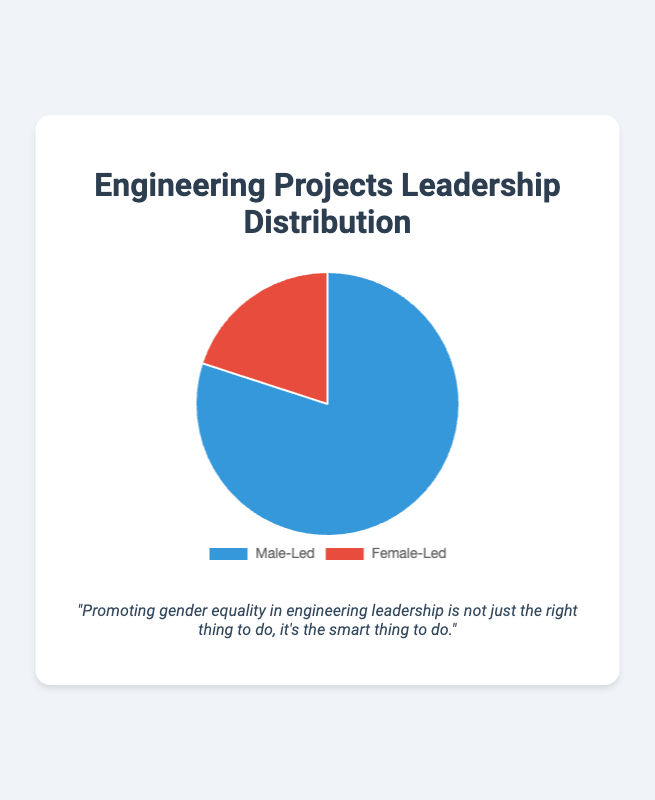Which group leads more engineering projects, Male-Led or Female-Led? The pie chart shows two segments representing Male-Led and Female-Led engineering projects. The Male-Led segment covers a larger portion of the chart.
Answer: Male-Led What is the percentage of engineering projects led by females? The pie chart labels each segment with its corresponding percentage. The Female-Led segment is labeled as 20%.
Answer: 20% What is the difference in the percentage of engineering projects led by males compared to females? The Male-Led projects account for 80%, while Female-Led projects account for 20%. The difference is 80% - 20%.
Answer: 60% If there are 100 engineering projects in total, how many of them are led by females? Given that 20% of the projects are led by females, if there are 100 total projects, then the number of Female-Led projects is 20% of 100.
Answer: 20 Estimate the ratio of Male-Led projects to Female-Led projects. The pie chart indicates 80% for Male-Led and 20% for Female-Led. The ratio can be calculated as 80:20, which simplifies to 4:1.
Answer: 4:1 How much more visually dominant is the Male-Led segment in terms of circle coverage compared to the Female-Led segment? The Male-Led segment occupies a much larger portion of the pie chart circle than the Female-Led segment. Visually, it's clear that the Male-Led segment covers four times the area of the Female-Led segment.
Answer: 4 times Is the color used for Female-Led projects warmer or cooler than the color for Male-Led projects? The Female-Led segment is colored red, which is a warm color, while the Male-Led segment is blue, which is a cool color.
Answer: Warmer If the total number of engineering projects is increased to 200, how many more Male-Led projects are there compared to Female-Led projects? With 200 total projects, 80% are Male-Led (0.80 * 200 = 160) and 20% are Female-Led (0.20 * 200 = 40). The difference is 160 - 40.
Answer: 120 What phrase is displayed as the gender equality quote below the pie chart? The phrase is shown directly below the pie chart and reads: "Promoting gender equality in engineering leadership is not just the right thing to do, it's the smart thing to do."
Answer: "Promoting gender equality in engineering leadership is not just the right thing to do, it's the smart thing to do." By what percentage would Female-Led projects need to increase to achieve an equal distribution of male and female-led projects? For an equal distribution, each group should lead 50% of the projects. Currently, Female-Led projects are at 20%. The increase needed is calculated as (50% - 20%) / 20% * 100%.
Answer: 150% 